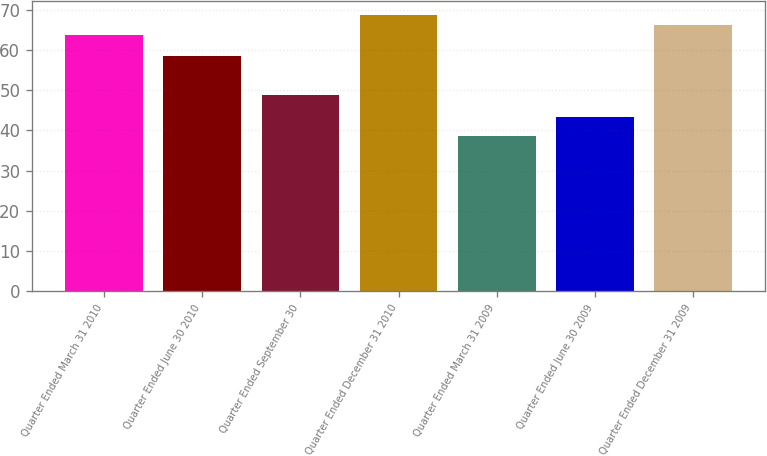Convert chart to OTSL. <chart><loc_0><loc_0><loc_500><loc_500><bar_chart><fcel>Quarter Ended March 31 2010<fcel>Quarter Ended June 30 2010<fcel>Quarter Ended September 30<fcel>Quarter Ended December 31 2010<fcel>Quarter Ended March 31 2009<fcel>Quarter Ended June 30 2009<fcel>Quarter Ended December 31 2009<nl><fcel>63.62<fcel>58.58<fcel>48.74<fcel>68.66<fcel>38.55<fcel>43.35<fcel>66.14<nl></chart> 